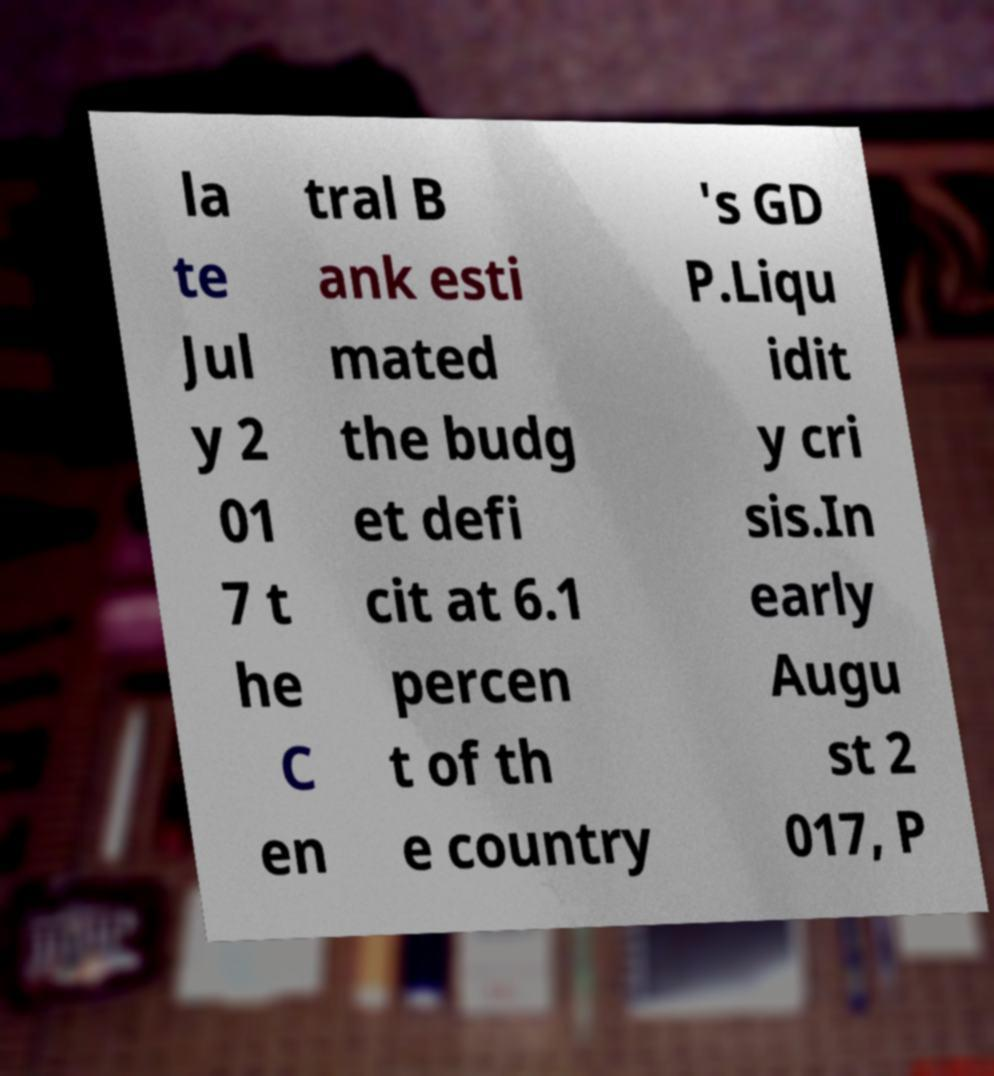What messages or text are displayed in this image? I need them in a readable, typed format. la te Jul y 2 01 7 t he C en tral B ank esti mated the budg et defi cit at 6.1 percen t of th e country 's GD P.Liqu idit y cri sis.In early Augu st 2 017, P 